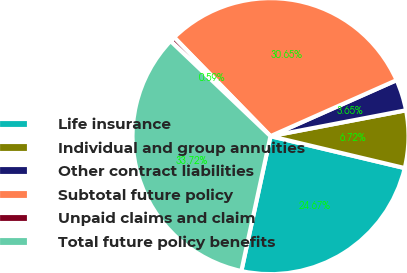Convert chart. <chart><loc_0><loc_0><loc_500><loc_500><pie_chart><fcel>Life insurance<fcel>Individual and group annuities<fcel>Other contract liabilities<fcel>Subtotal future policy<fcel>Unpaid claims and claim<fcel>Total future policy benefits<nl><fcel>24.67%<fcel>6.72%<fcel>3.65%<fcel>30.65%<fcel>0.59%<fcel>33.72%<nl></chart> 